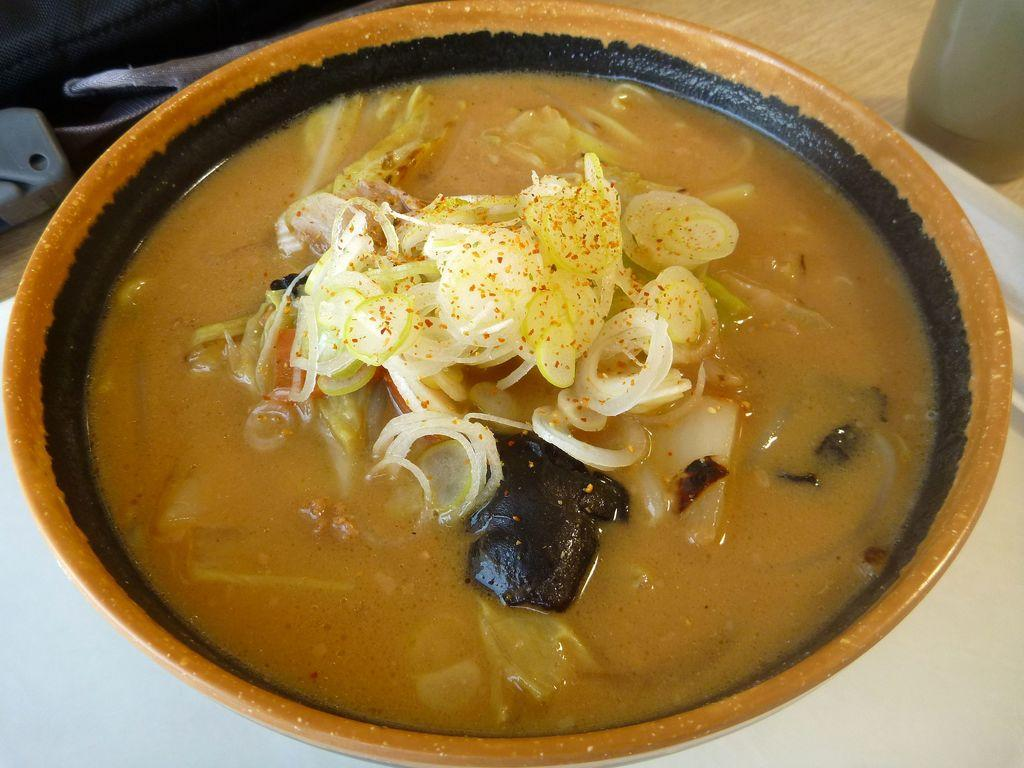What is the main subject of the image? There is a food item in the image. How is the food item presented in the image? The food item is in a bowl. How many jellyfish can be seen playing in the bowl in the image? There are no jellyfish present in the image, and the food item is not engaged in any playful activities. 